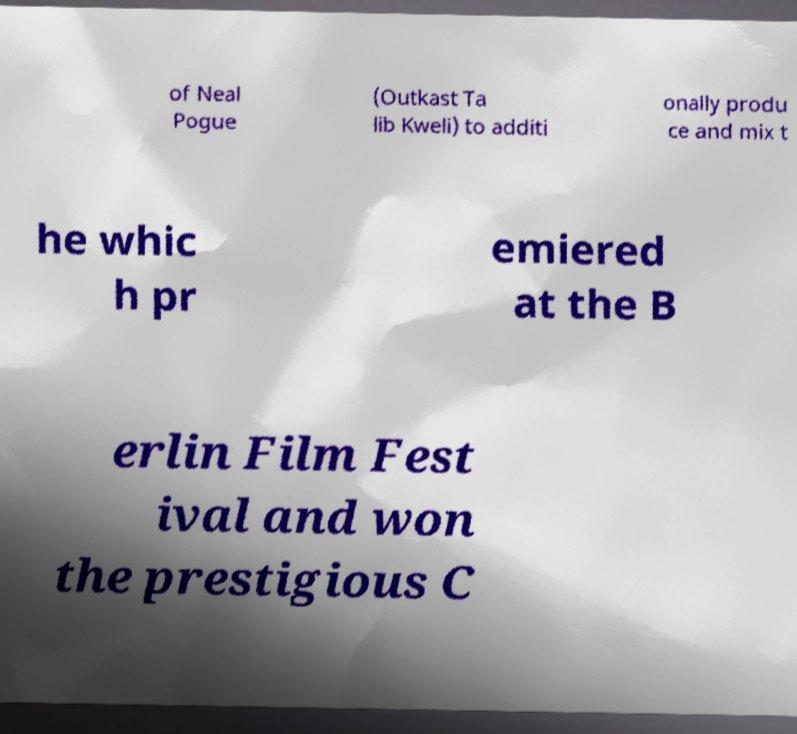There's text embedded in this image that I need extracted. Can you transcribe it verbatim? of Neal Pogue (Outkast Ta lib Kweli) to additi onally produ ce and mix t he whic h pr emiered at the B erlin Film Fest ival and won the prestigious C 